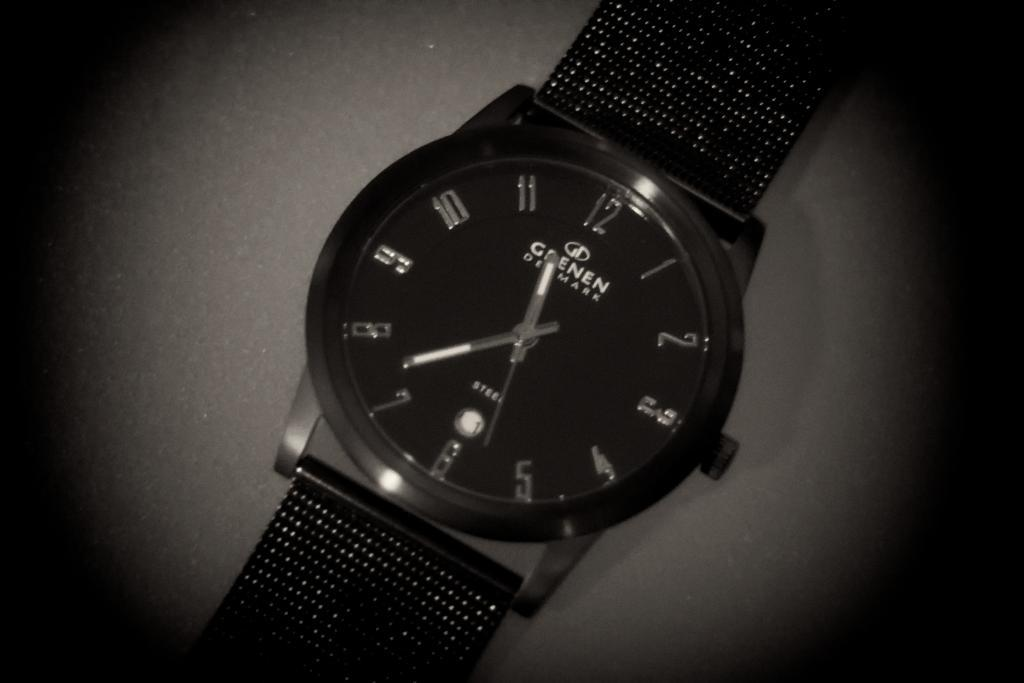<image>
Describe the image concisely. A watch from Denmark is shown in a black and white closeup. 